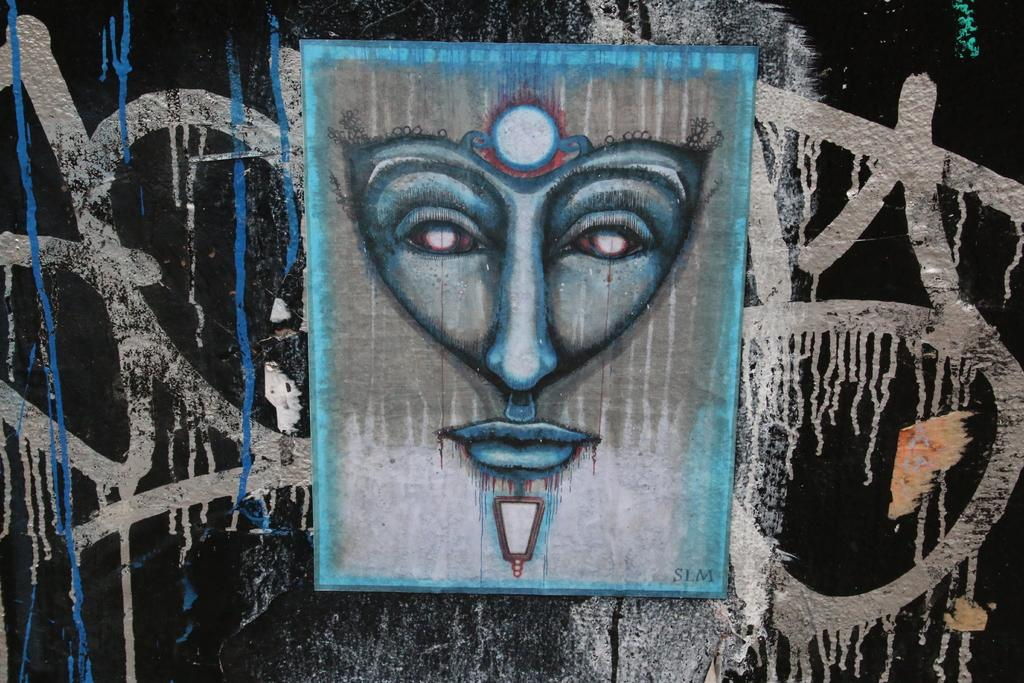What type of artwork is visible in the image? There is graffiti painting in the image. What color is the wall on which the graffiti painting is done? The wall is black. Where is the wall located in the image? The wall is in the foreground of the image. What type of machine is used to create the weather depicted in the graffiti painting? There is no machine or weather depicted in the graffiti painting; it is an artwork on a black wall. How many matches are used to light the graffiti painting in the image? There are no matches or indication of fire in the graffiti painting or the image. 